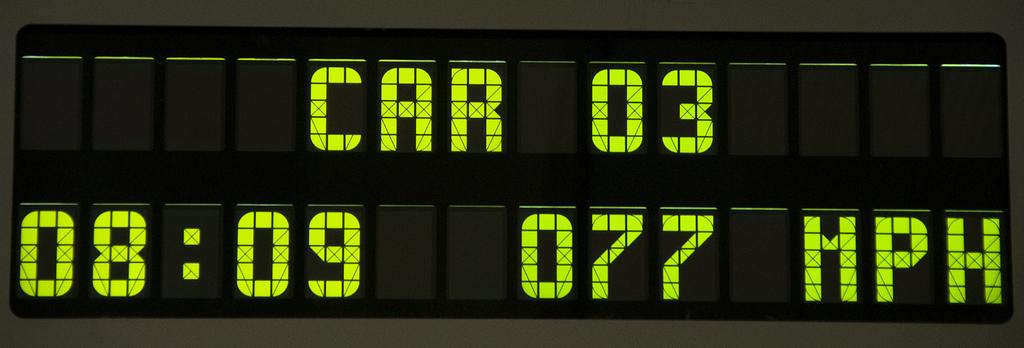How fast is car 03 traveling?
Provide a short and direct response. 77 mph. What unit does the sign measure speed in?
Ensure brevity in your answer.  Mph. 